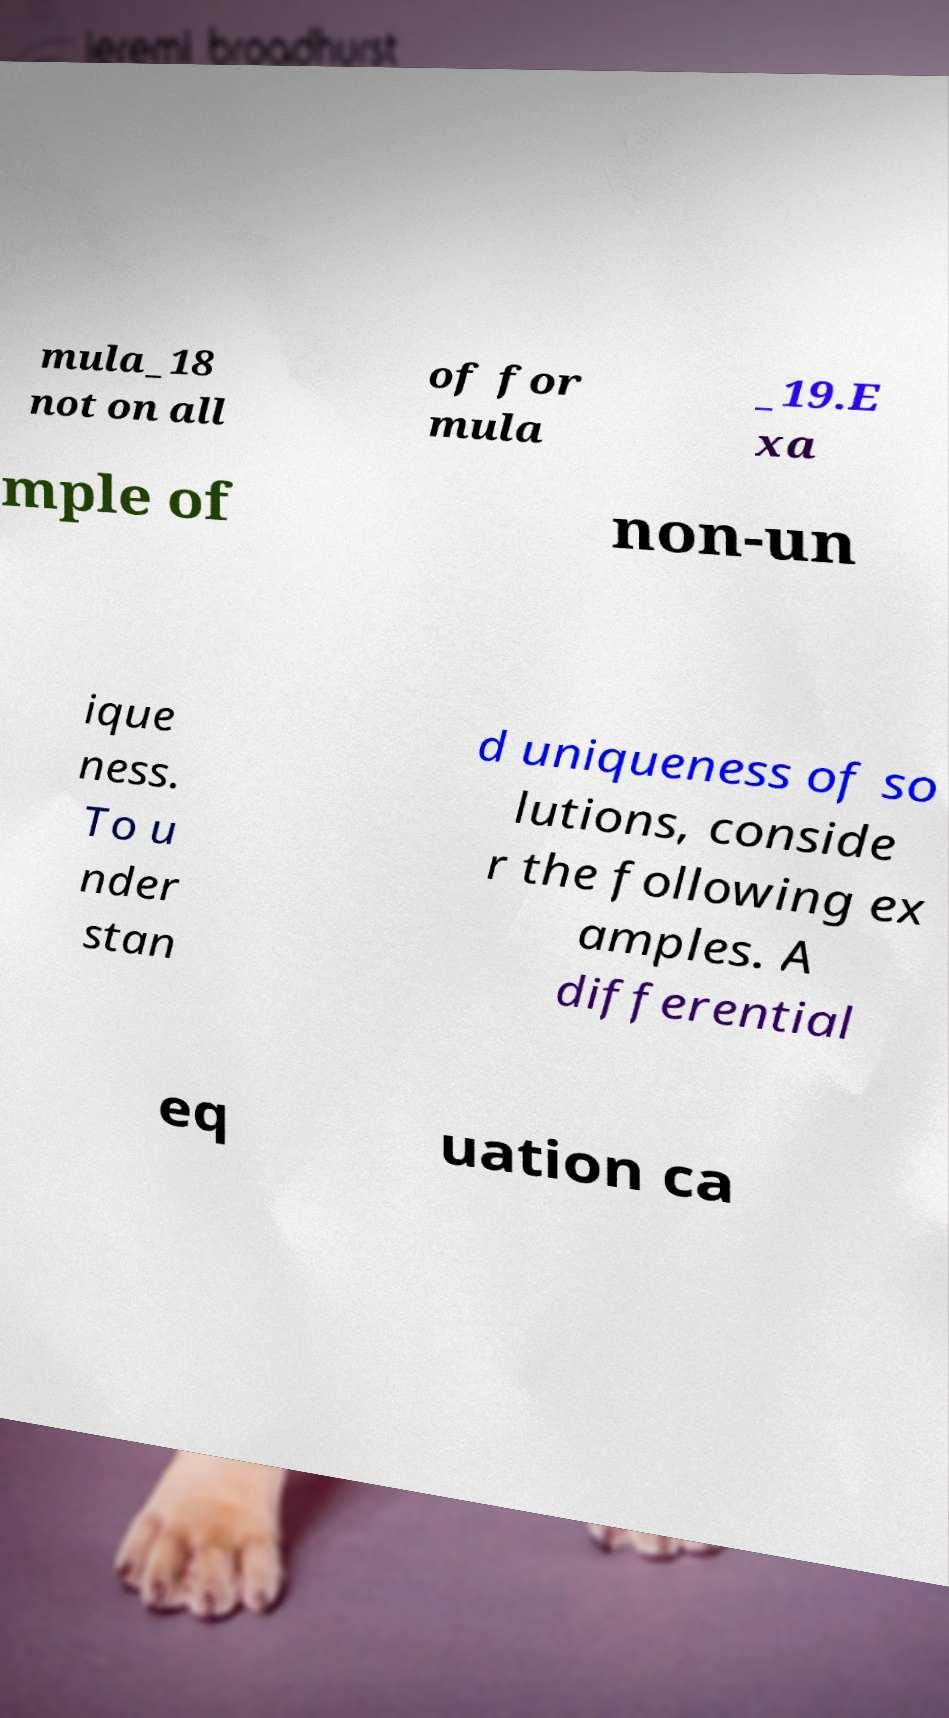Please read and relay the text visible in this image. What does it say? mula_18 not on all of for mula _19.E xa mple of non-un ique ness. To u nder stan d uniqueness of so lutions, conside r the following ex amples. A differential eq uation ca 